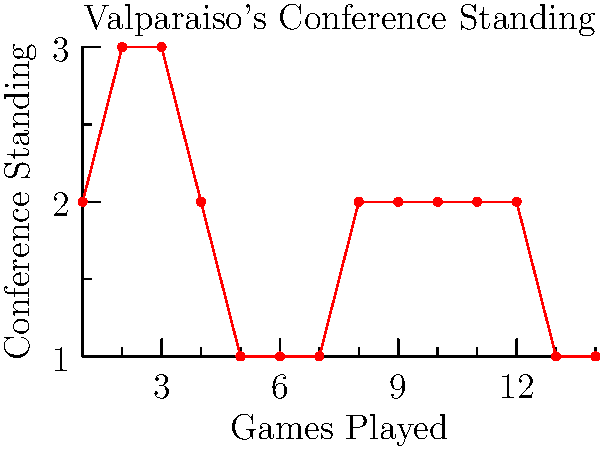Based on the line graph representing Valparaiso's conference standings throughout the 1998-99 season, in how many games did Valparaiso hold the top position in the conference? To answer this question, we need to analyze the graph step-by-step:

1. The y-axis represents the conference standing, where 1 is the top position.
2. The x-axis represents the number of games played.
3. We need to count how many times the line touches the y-value of 1.

Examining the graph:
- The line first reaches y=1 at x=5 (5th game).
- It stays at y=1 for games 5, 6, and 7.
- The line then moves up (lower position) and never returns to y=1.

Therefore, Valparaiso held the top position (y=1) for 3 consecutive games.
Answer: 3 games 